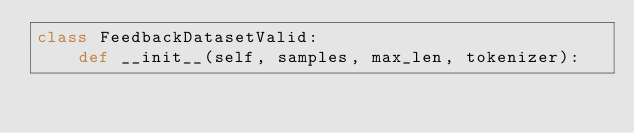<code> <loc_0><loc_0><loc_500><loc_500><_Python_>class FeedbackDatasetValid:
    def __init__(self, samples, max_len, tokenizer):</code> 